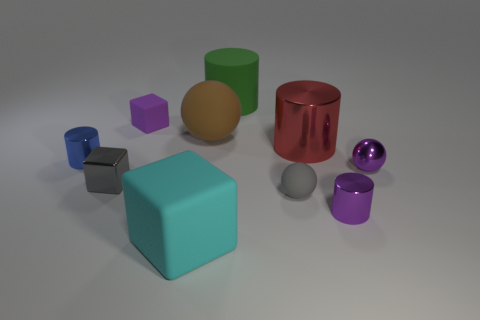Subtract all purple metallic balls. How many balls are left? 2 Subtract all purple balls. How many balls are left? 2 Subtract 1 blocks. How many blocks are left? 2 Subtract 0 blue balls. How many objects are left? 10 Subtract all cubes. How many objects are left? 7 Subtract all cyan balls. Subtract all cyan blocks. How many balls are left? 3 Subtract all big rubber blocks. Subtract all large brown rubber objects. How many objects are left? 8 Add 5 large brown objects. How many large brown objects are left? 6 Add 3 large brown matte spheres. How many large brown matte spheres exist? 4 